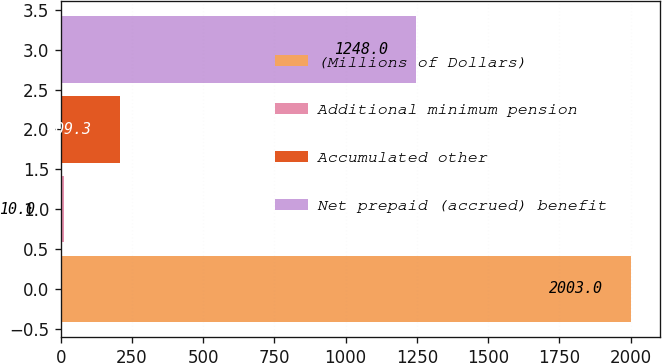Convert chart. <chart><loc_0><loc_0><loc_500><loc_500><bar_chart><fcel>(Millions of Dollars)<fcel>Additional minimum pension<fcel>Accumulated other<fcel>Net prepaid (accrued) benefit<nl><fcel>2003<fcel>10<fcel>209.3<fcel>1248<nl></chart> 